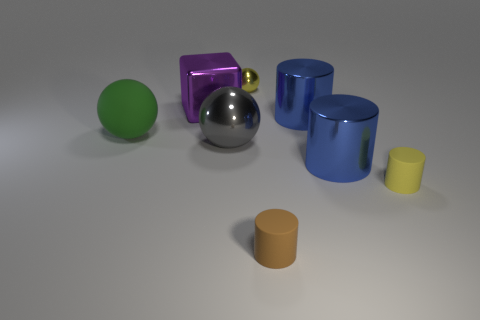Subtract all large spheres. How many spheres are left? 1 Subtract all yellow balls. How many balls are left? 2 Subtract 1 blocks. How many blocks are left? 0 Subtract all balls. How many objects are left? 5 Add 1 large green matte things. How many objects exist? 9 Subtract all green balls. Subtract all purple cylinders. How many balls are left? 2 Subtract all red cubes. How many yellow balls are left? 1 Subtract all blue matte balls. Subtract all small yellow objects. How many objects are left? 6 Add 1 tiny yellow metal balls. How many tiny yellow metal balls are left? 2 Add 6 large yellow metal cylinders. How many large yellow metal cylinders exist? 6 